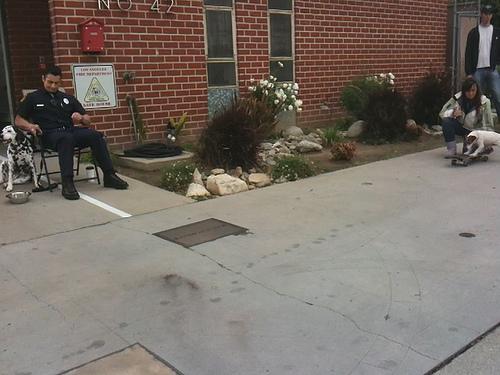What surface is the man resting his feet on?
Be succinct. Concrete. Is there a person on the ground?
Be succinct. Yes. What is the sidewalk like?
Quick response, please. Dirty. What animal is in front of the door?
Concise answer only. Dog. Where is the man?
Give a very brief answer. Chair. What is the person wearing?
Answer briefly. Uniform. What is the person holding?
Give a very brief answer. Leash. What animal is in the picture?
Quick response, please. Dog. Where is the window?
Keep it brief. On building. What is the lady sitting on?
Short answer required. Sidewalk. What kind of bird is on the sidewalk?
Answer briefly. None. How many people could find a place to sit in this location?
Write a very short answer. 1. Is the man wearing a scarf?
Give a very brief answer. No. What kind of animals are shown?
Concise answer only. Dogs. Is there a cup on the sidewalk?
Answer briefly. No. What kind of dog is sitting next to the man?
Be succinct. Dalmatian. Does the man have good balance?
Be succinct. Yes. Is the man a police officer?
Quick response, please. Yes. What is the parking lot paved with?
Quick response, please. Concrete. 